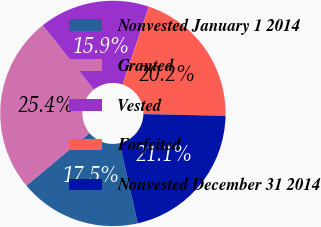Convert chart. <chart><loc_0><loc_0><loc_500><loc_500><pie_chart><fcel>Nonvested January 1 2014<fcel>Granted<fcel>Vested<fcel>Forfeited<fcel>Nonvested December 31 2014<nl><fcel>17.48%<fcel>25.36%<fcel>15.87%<fcel>20.17%<fcel>21.12%<nl></chart> 